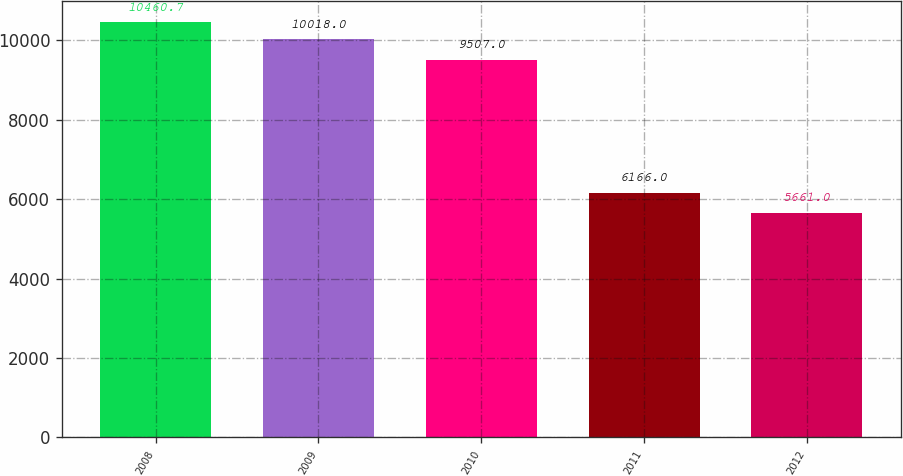Convert chart to OTSL. <chart><loc_0><loc_0><loc_500><loc_500><bar_chart><fcel>2008<fcel>2009<fcel>2010<fcel>2011<fcel>2012<nl><fcel>10460.7<fcel>10018<fcel>9507<fcel>6166<fcel>5661<nl></chart> 